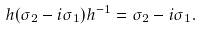Convert formula to latex. <formula><loc_0><loc_0><loc_500><loc_500>h ( \sigma _ { 2 } - i \sigma _ { 1 } ) h ^ { - 1 } = \sigma _ { 2 } - i \sigma _ { 1 } .</formula> 